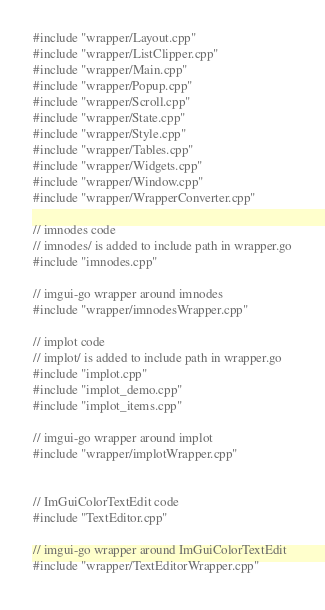<code> <loc_0><loc_0><loc_500><loc_500><_C++_>#include "wrapper/Layout.cpp"
#include "wrapper/ListClipper.cpp"
#include "wrapper/Main.cpp"
#include "wrapper/Popup.cpp"
#include "wrapper/Scroll.cpp"
#include "wrapper/State.cpp"
#include "wrapper/Style.cpp"
#include "wrapper/Tables.cpp"
#include "wrapper/Widgets.cpp"
#include "wrapper/Window.cpp"
#include "wrapper/WrapperConverter.cpp"

// imnodes code
// imnodes/ is added to include path in wrapper.go
#include "imnodes.cpp"

// imgui-go wrapper around imnodes
#include "wrapper/imnodesWrapper.cpp"

// implot code
// implot/ is added to include path in wrapper.go
#include "implot.cpp"
#include "implot_demo.cpp"
#include "implot_items.cpp"

// imgui-go wrapper around implot
#include "wrapper/implotWrapper.cpp"


// ImGuiColorTextEdit code
#include "TextEditor.cpp"

// imgui-go wrapper around ImGuiColorTextEdit
#include "wrapper/TextEditorWrapper.cpp"</code> 